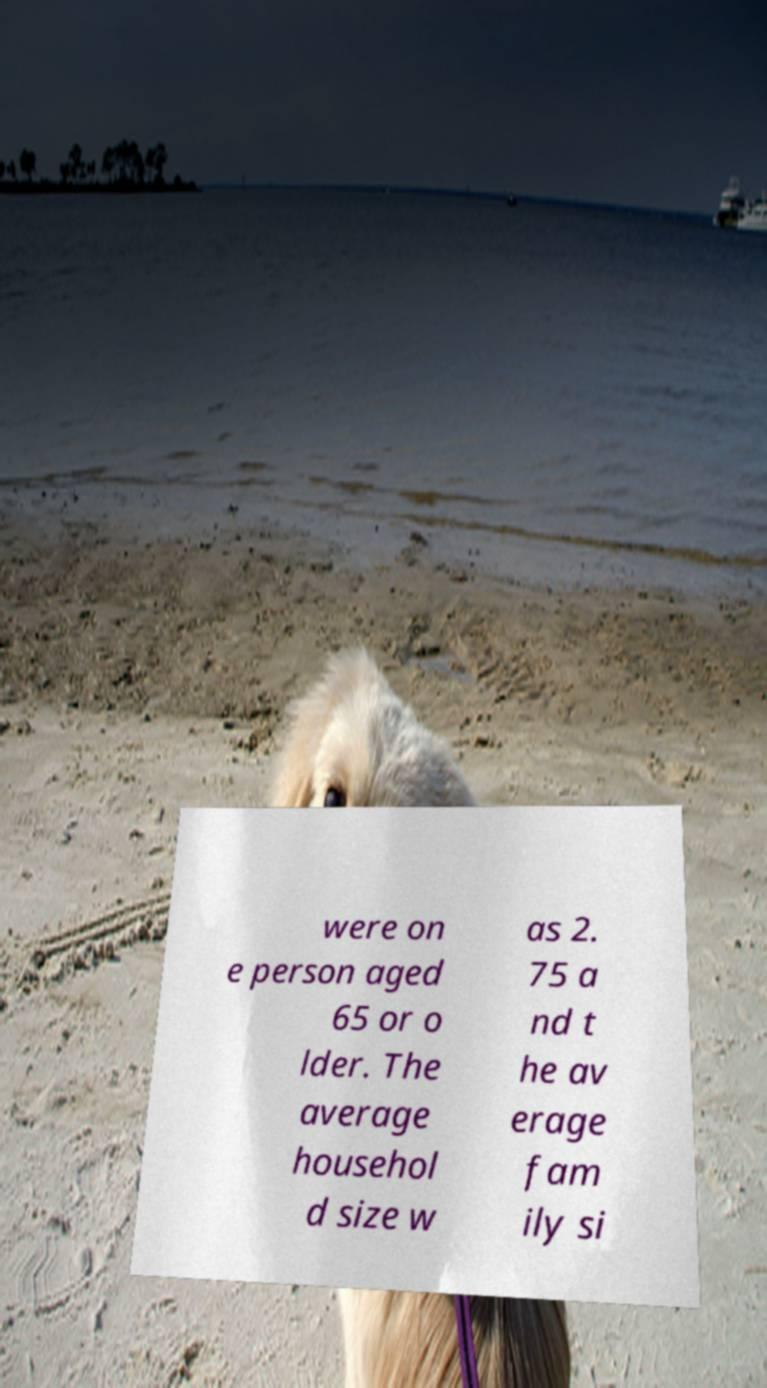What messages or text are displayed in this image? I need them in a readable, typed format. were on e person aged 65 or o lder. The average househol d size w as 2. 75 a nd t he av erage fam ily si 